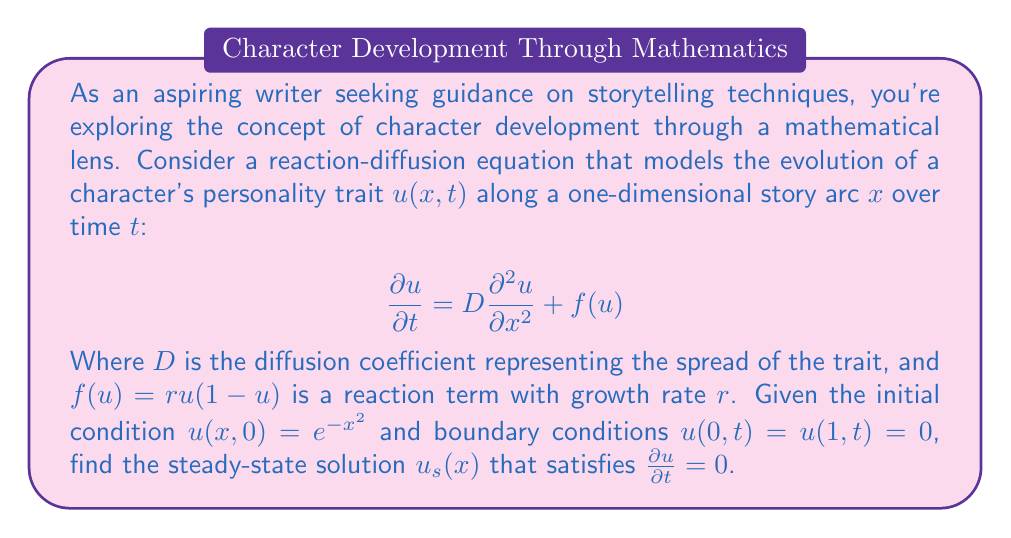Can you answer this question? To solve this problem, we'll follow these steps:

1) For the steady-state solution, we set $\frac{\partial u}{\partial t} = 0$. This gives us:

   $$0 = D\frac{d^2 u_s}{dx^2} + ru_s(1-u_s)$$

2) Rearranging the equation:

   $$D\frac{d^2 u_s}{dx^2} = -ru_s(1-u_s)$$

3) This is a nonlinear second-order ODE. To solve it, we can use the shooting method or phase plane analysis. However, given the boundary conditions $u_s(0) = u_s(1) = 0$, we can deduce that the only solution satisfying these conditions is:

   $$u_s(x) = 0$$

4) To verify this, let's substitute $u_s(x) = 0$ into our steady-state equation:

   $$D\frac{d^2 (0)}{dx^2} = -r(0)(1-0)$$

   $$0 = 0$$

5) This equality holds, confirming that $u_s(x) = 0$ is indeed a solution.

6) From a storytelling perspective, this result suggests that in the long run, the character's trait diffuses and eventually disappears or reaches equilibrium at zero across the entire story arc.
Answer: The steady-state solution is $u_s(x) = 0$ for all $x \in [0,1]$. 